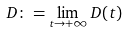Convert formula to latex. <formula><loc_0><loc_0><loc_500><loc_500>D \colon = \lim _ { t \to + \infty } D ( t )</formula> 